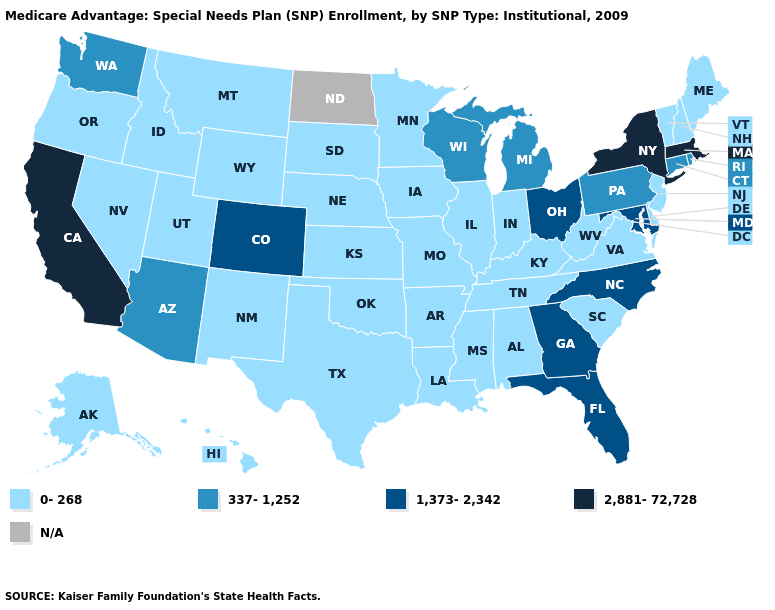What is the value of Arizona?
Keep it brief. 337-1,252. Is the legend a continuous bar?
Write a very short answer. No. What is the lowest value in states that border North Dakota?
Answer briefly. 0-268. Name the states that have a value in the range 0-268?
Give a very brief answer. Alaska, Alabama, Arkansas, Delaware, Hawaii, Iowa, Idaho, Illinois, Indiana, Kansas, Kentucky, Louisiana, Maine, Minnesota, Missouri, Mississippi, Montana, Nebraska, New Hampshire, New Jersey, New Mexico, Nevada, Oklahoma, Oregon, South Carolina, South Dakota, Tennessee, Texas, Utah, Virginia, Vermont, West Virginia, Wyoming. What is the value of New York?
Give a very brief answer. 2,881-72,728. What is the value of Kansas?
Short answer required. 0-268. Name the states that have a value in the range N/A?
Write a very short answer. North Dakota. What is the lowest value in the MidWest?
Keep it brief. 0-268. What is the value of Montana?
Short answer required. 0-268. What is the lowest value in the USA?
Give a very brief answer. 0-268. What is the highest value in states that border Montana?
Keep it brief. 0-268. What is the value of Montana?
Concise answer only. 0-268. Name the states that have a value in the range N/A?
Quick response, please. North Dakota. Among the states that border Missouri , which have the highest value?
Give a very brief answer. Arkansas, Iowa, Illinois, Kansas, Kentucky, Nebraska, Oklahoma, Tennessee. 